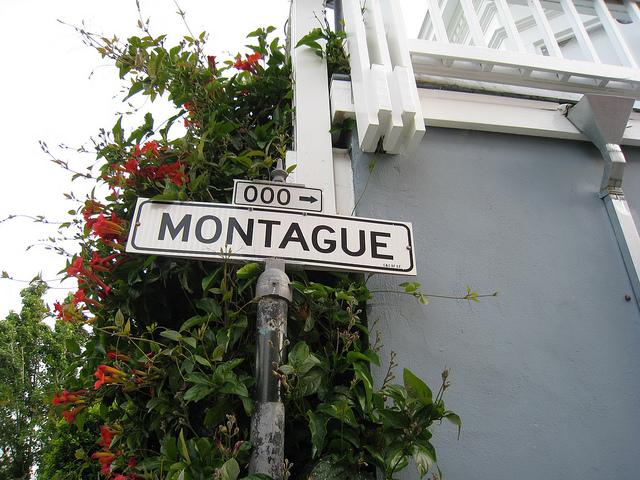Are there any plants near the sign?
Concise answer only. Yes. Does the tree branch curve to the left or to the right?
Give a very brief answer. Left. What number is above the sign?
Be succinct. 000. What kind of plant is this?
Keep it brief. Bush. 